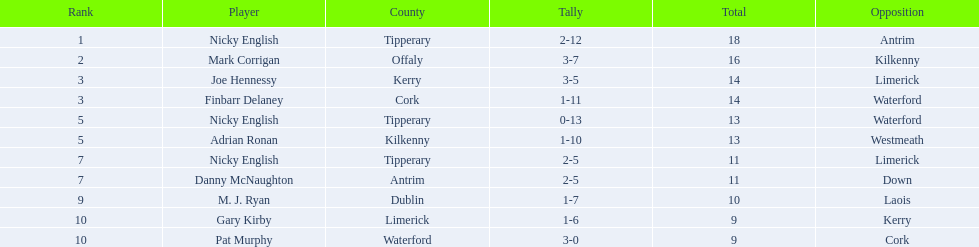In the total column, what numbers are listed? 18, 16, 14, 14, 13, 13, 11, 11, 10, 9, 9. In which row does the total column show the number 10? 9, M. J. Ryan, Dublin, 1-7, 10, Laois. For this row, what is the player's name in the player column? M. J. Ryan. 